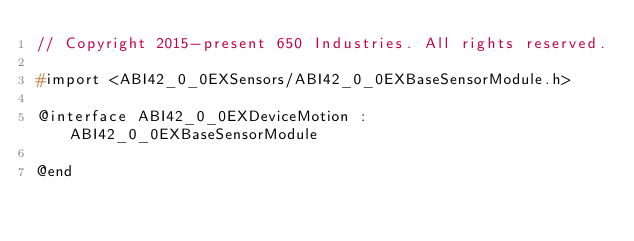Convert code to text. <code><loc_0><loc_0><loc_500><loc_500><_C_>// Copyright 2015-present 650 Industries. All rights reserved.

#import <ABI42_0_0EXSensors/ABI42_0_0EXBaseSensorModule.h>

@interface ABI42_0_0EXDeviceMotion : ABI42_0_0EXBaseSensorModule

@end
</code> 